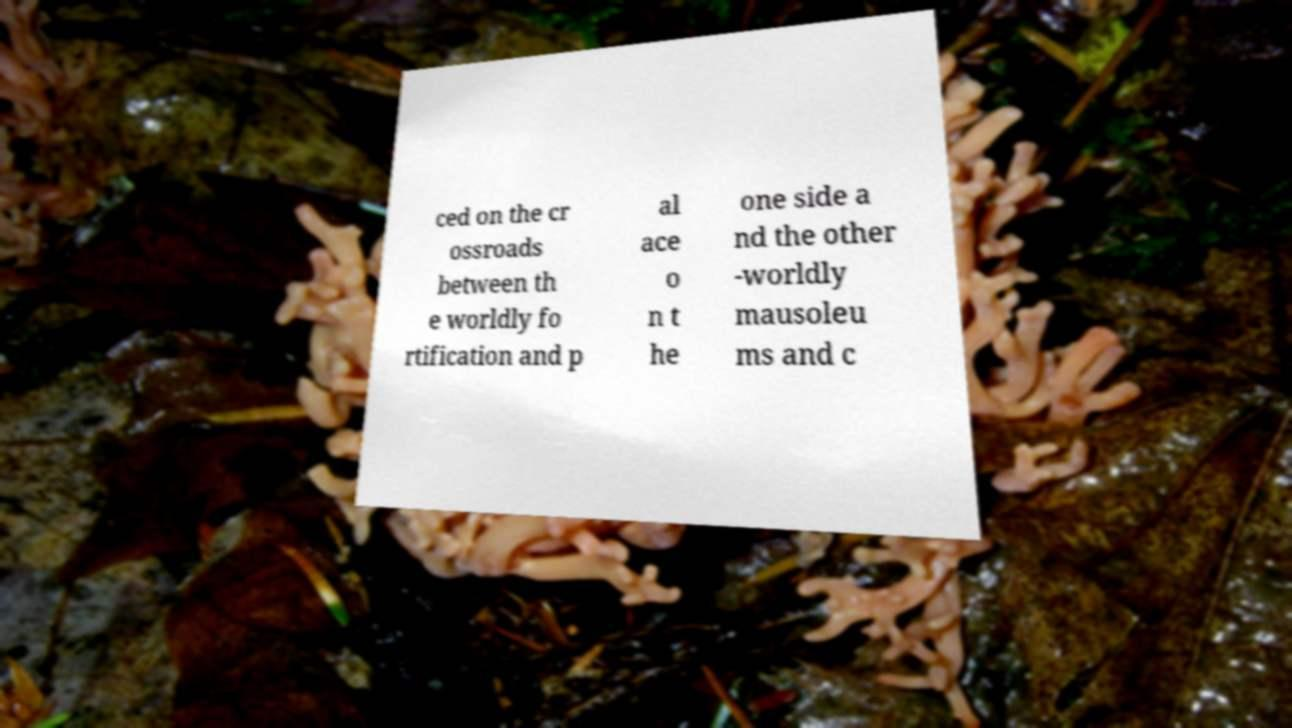There's text embedded in this image that I need extracted. Can you transcribe it verbatim? ced on the cr ossroads between th e worldly fo rtification and p al ace o n t he one side a nd the other -worldly mausoleu ms and c 